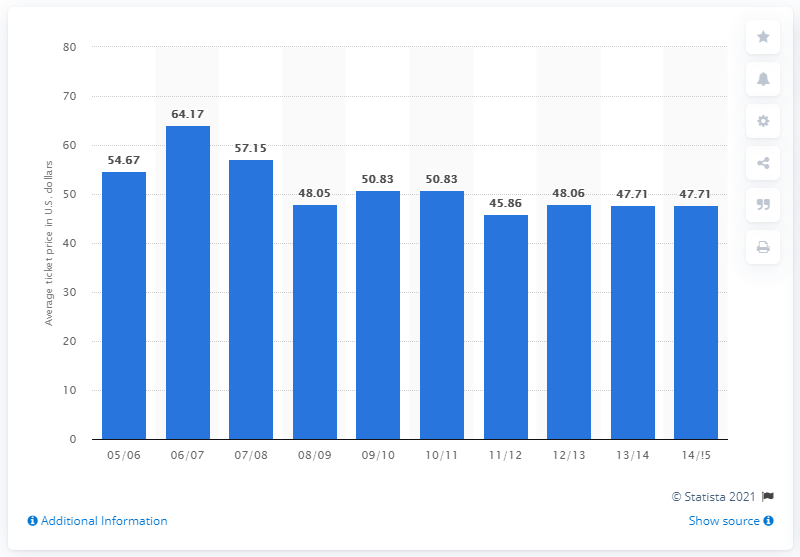List a handful of essential elements in this visual. The average ticket price for the 2005/2006 season was 54.67 dollars. 